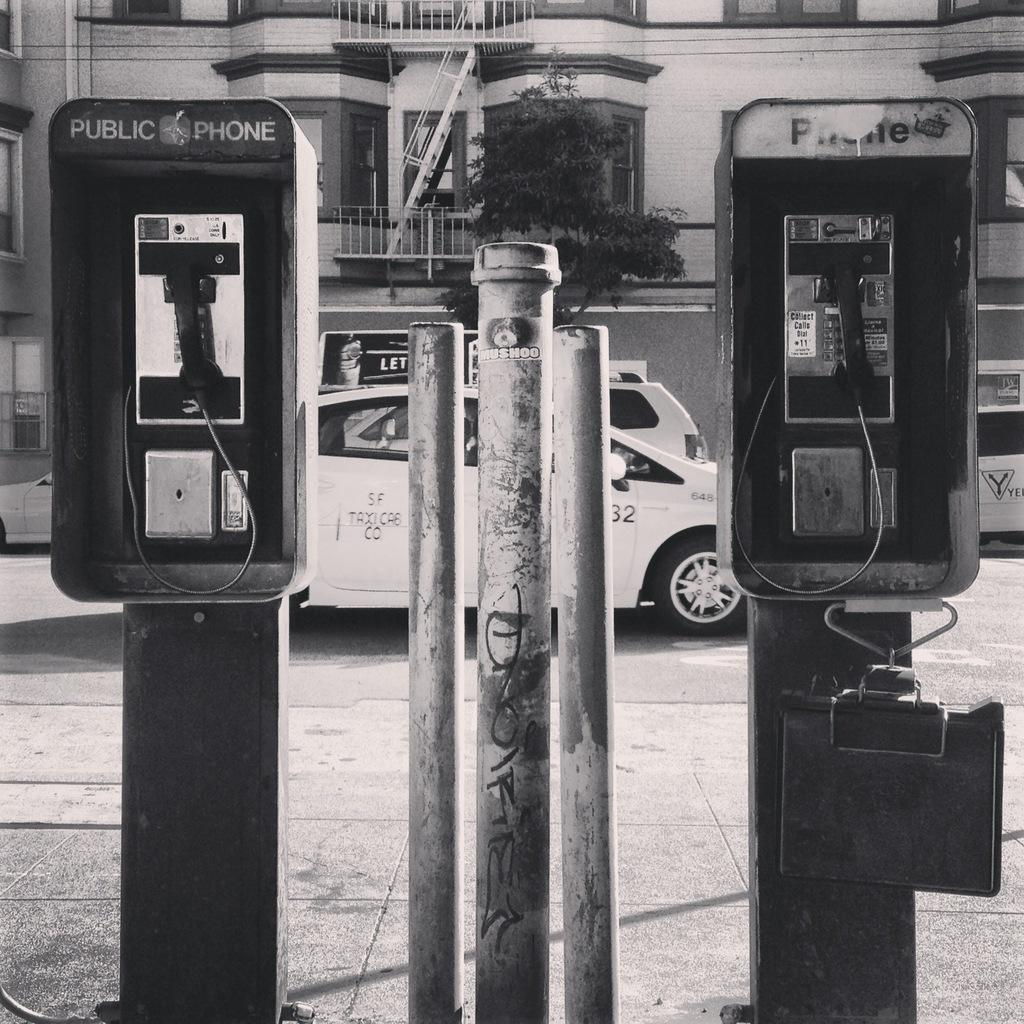<image>
Render a clear and concise summary of the photo. Telephone booth which says "Public Phone" on the top. 